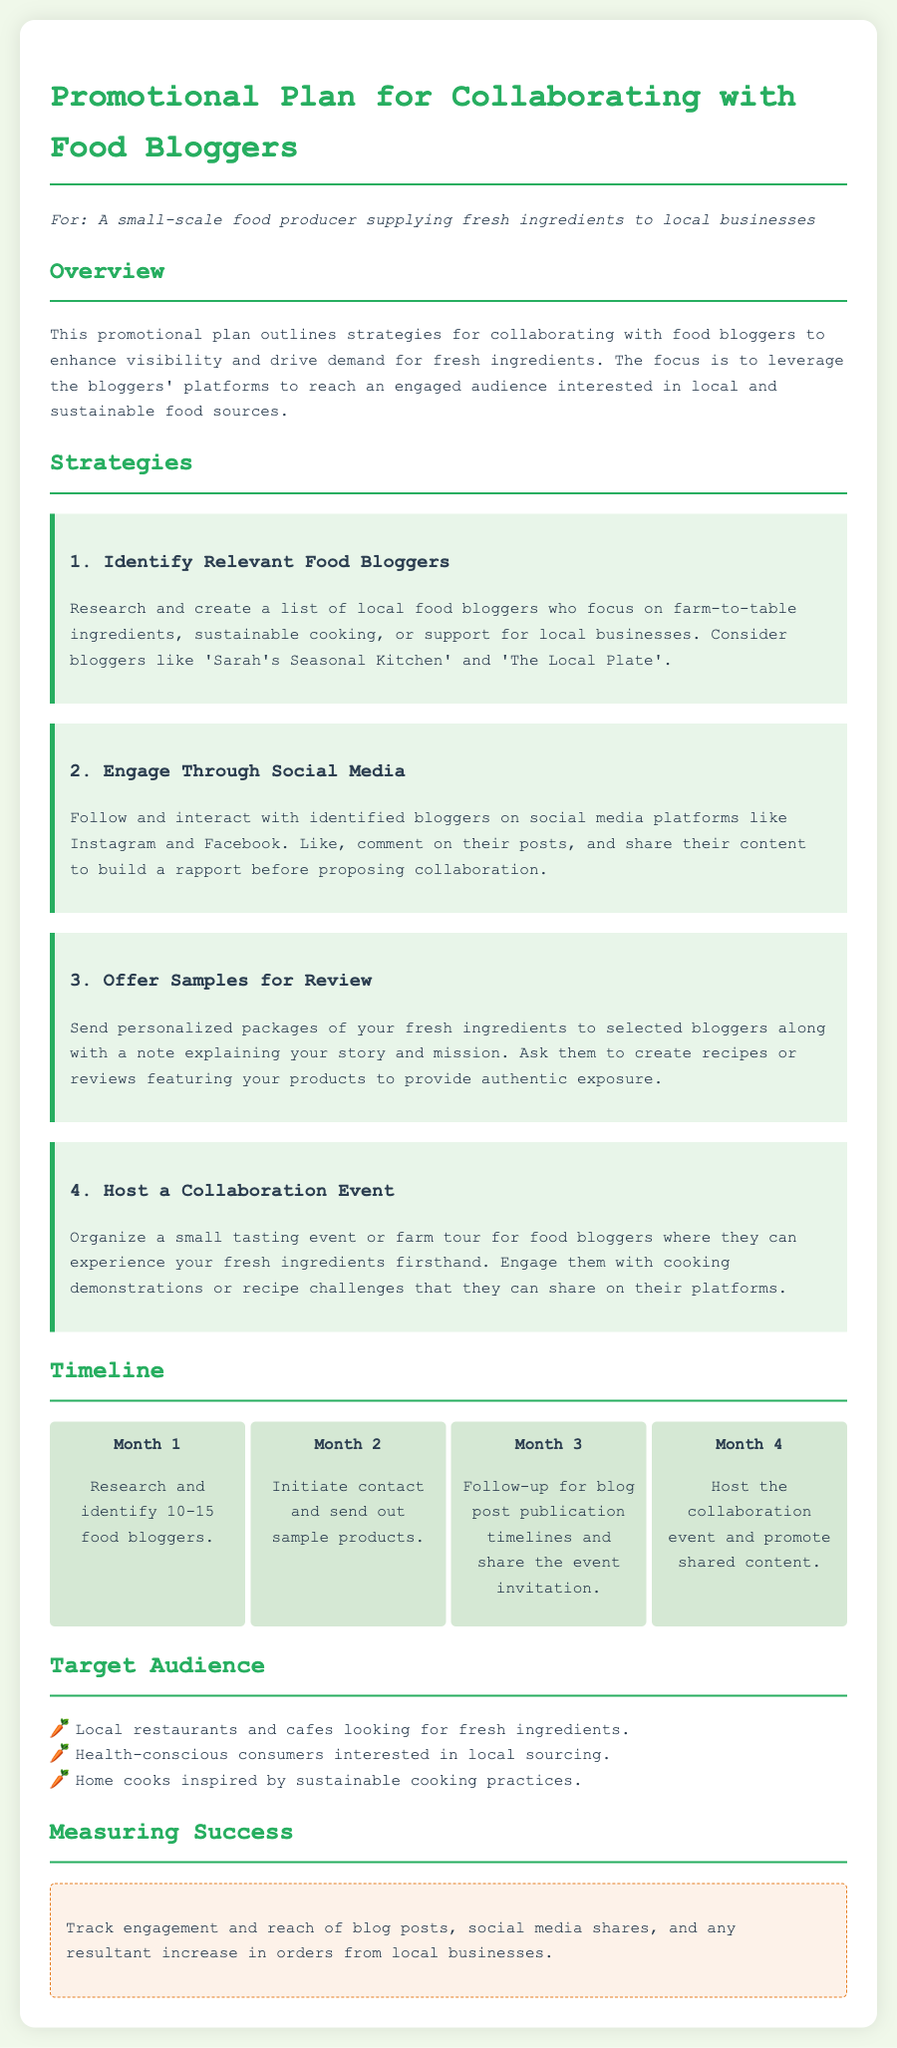What are the names of two food bloggers mentioned? The document lists 'Sarah's Seasonal Kitchen' and 'The Local Plate' as relevant food bloggers.
Answer: Sarah's Seasonal Kitchen, The Local Plate What is the focus of the promotional plan? The plan focuses on enhancing visibility and demand for fresh ingredients through collaboration with food bloggers.
Answer: Enhancing visibility and demand for fresh ingredients How many food bloggers should be identified in Month 1? The document states that 10-15 food bloggers should be researched and identified during the first month.
Answer: 10-15 What is one way to engage with food bloggers on social media? The promotional plan suggests following and interacting by liking and commenting on their posts.
Answer: Like and comment on their posts What is the target audience for the promotional plan? The target audience includes local restaurants, health-conscious consumers, and home cooks inspired by sustainable cooking.
Answer: Local restaurants, health-conscious consumers, home cooks What should be included in the packages sent to food bloggers? The packages should include personalized notes explaining the producer's story along with fresh ingredients.
Answer: Personalized notes and fresh ingredients In which month is the collaboration event scheduled to be hosted? The event is planned to be hosted in Month 4 of the timeline.
Answer: Month 4 What metric is suggested for measuring success? The document advises tracking engagement and reach of blog posts and social media shares as a measure of success.
Answer: Engagement and reach of blog posts 